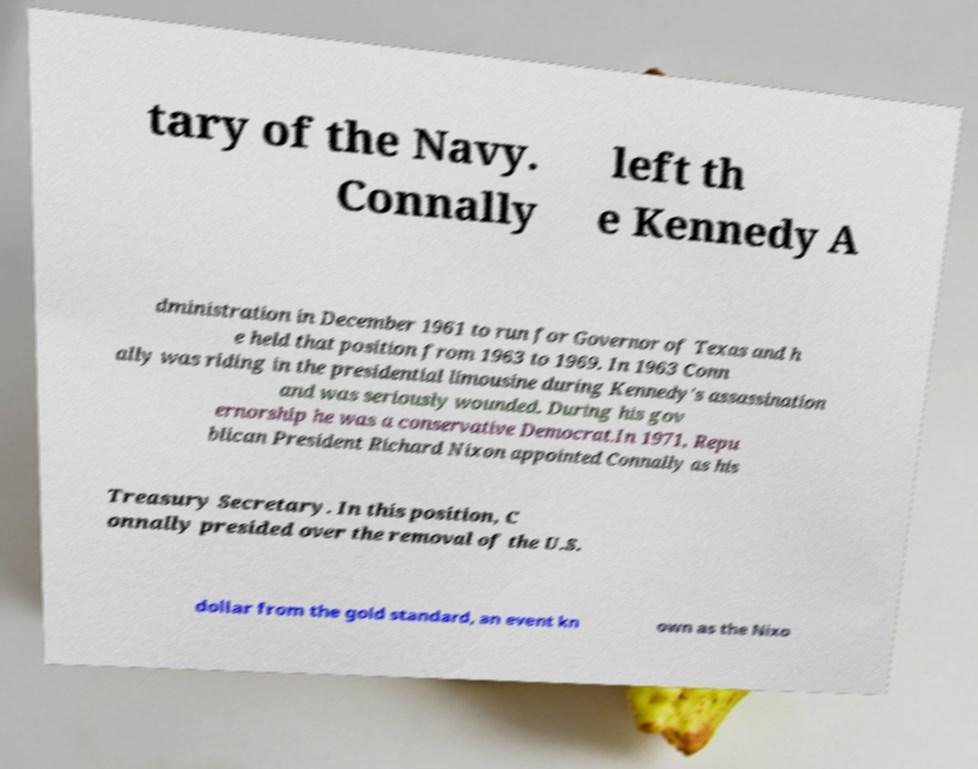Can you accurately transcribe the text from the provided image for me? tary of the Navy. Connally left th e Kennedy A dministration in December 1961 to run for Governor of Texas and h e held that position from 1963 to 1969. In 1963 Conn ally was riding in the presidential limousine during Kennedy's assassination and was seriously wounded. During his gov ernorship he was a conservative Democrat.In 1971, Repu blican President Richard Nixon appointed Connally as his Treasury Secretary. In this position, C onnally presided over the removal of the U.S. dollar from the gold standard, an event kn own as the Nixo 